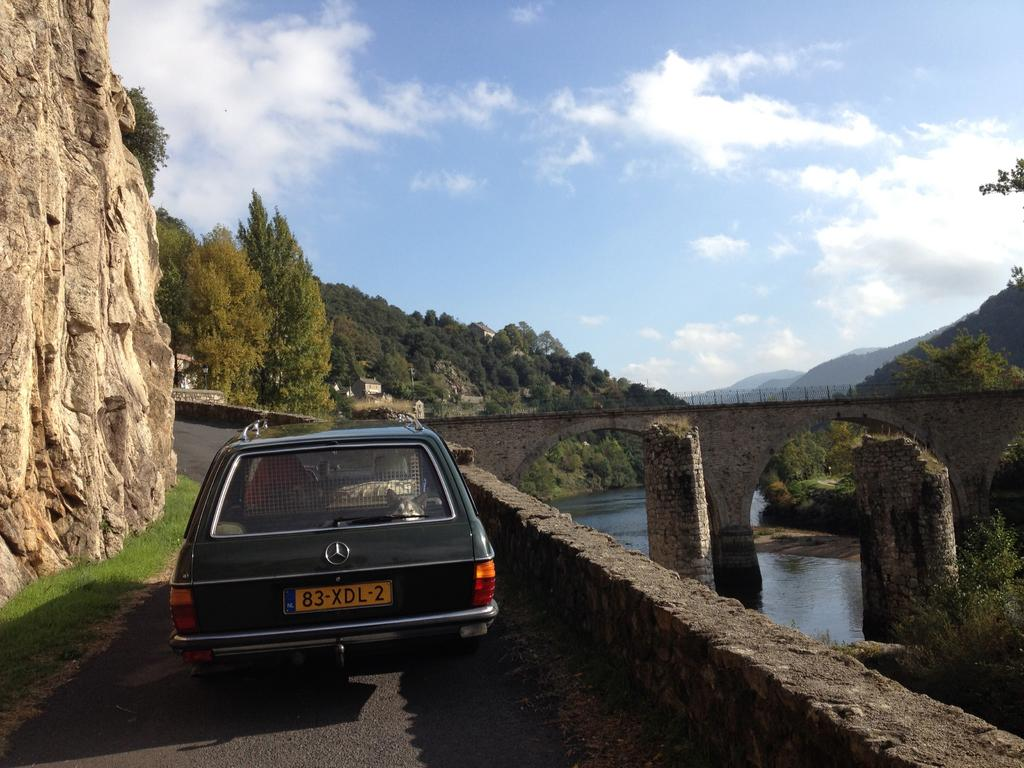What type of structure can be seen in the image? There is a bridge in the image. What other object can be seen in the image? There is a fence in the image. What mode of transportation is present in the image? There is a car on the road in the image. What type of natural environment is visible in the background of the image? There are trees, hills, and water visible in the background of the image. What is visible in the sky at the top of the image? There are clouds in the sky at the top of the image. What type of yarn is being used to create the scale model of the bridge in the image? There is no yarn or scale model present in the image; it features a real bridge. How many tomatoes are growing on the fence in the image? There are no tomatoes present in the image; it features a fence and a bridge. 